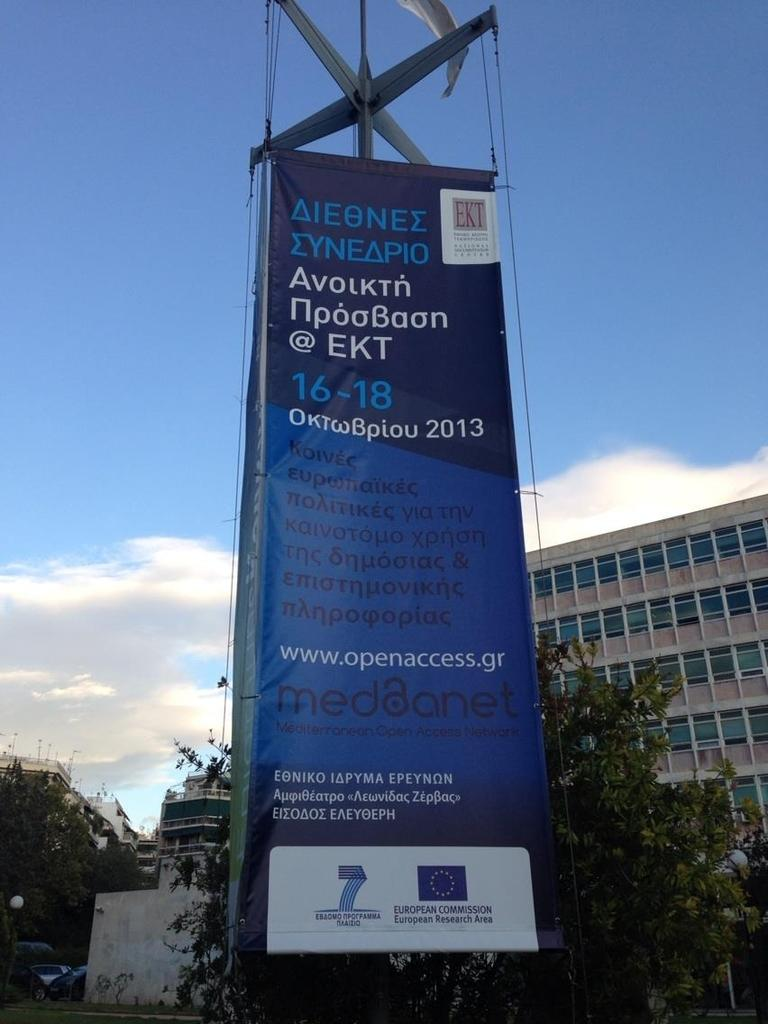<image>
Present a compact description of the photo's key features. A big blue sign in front of a building with writing in foreign language advertising medanet. 